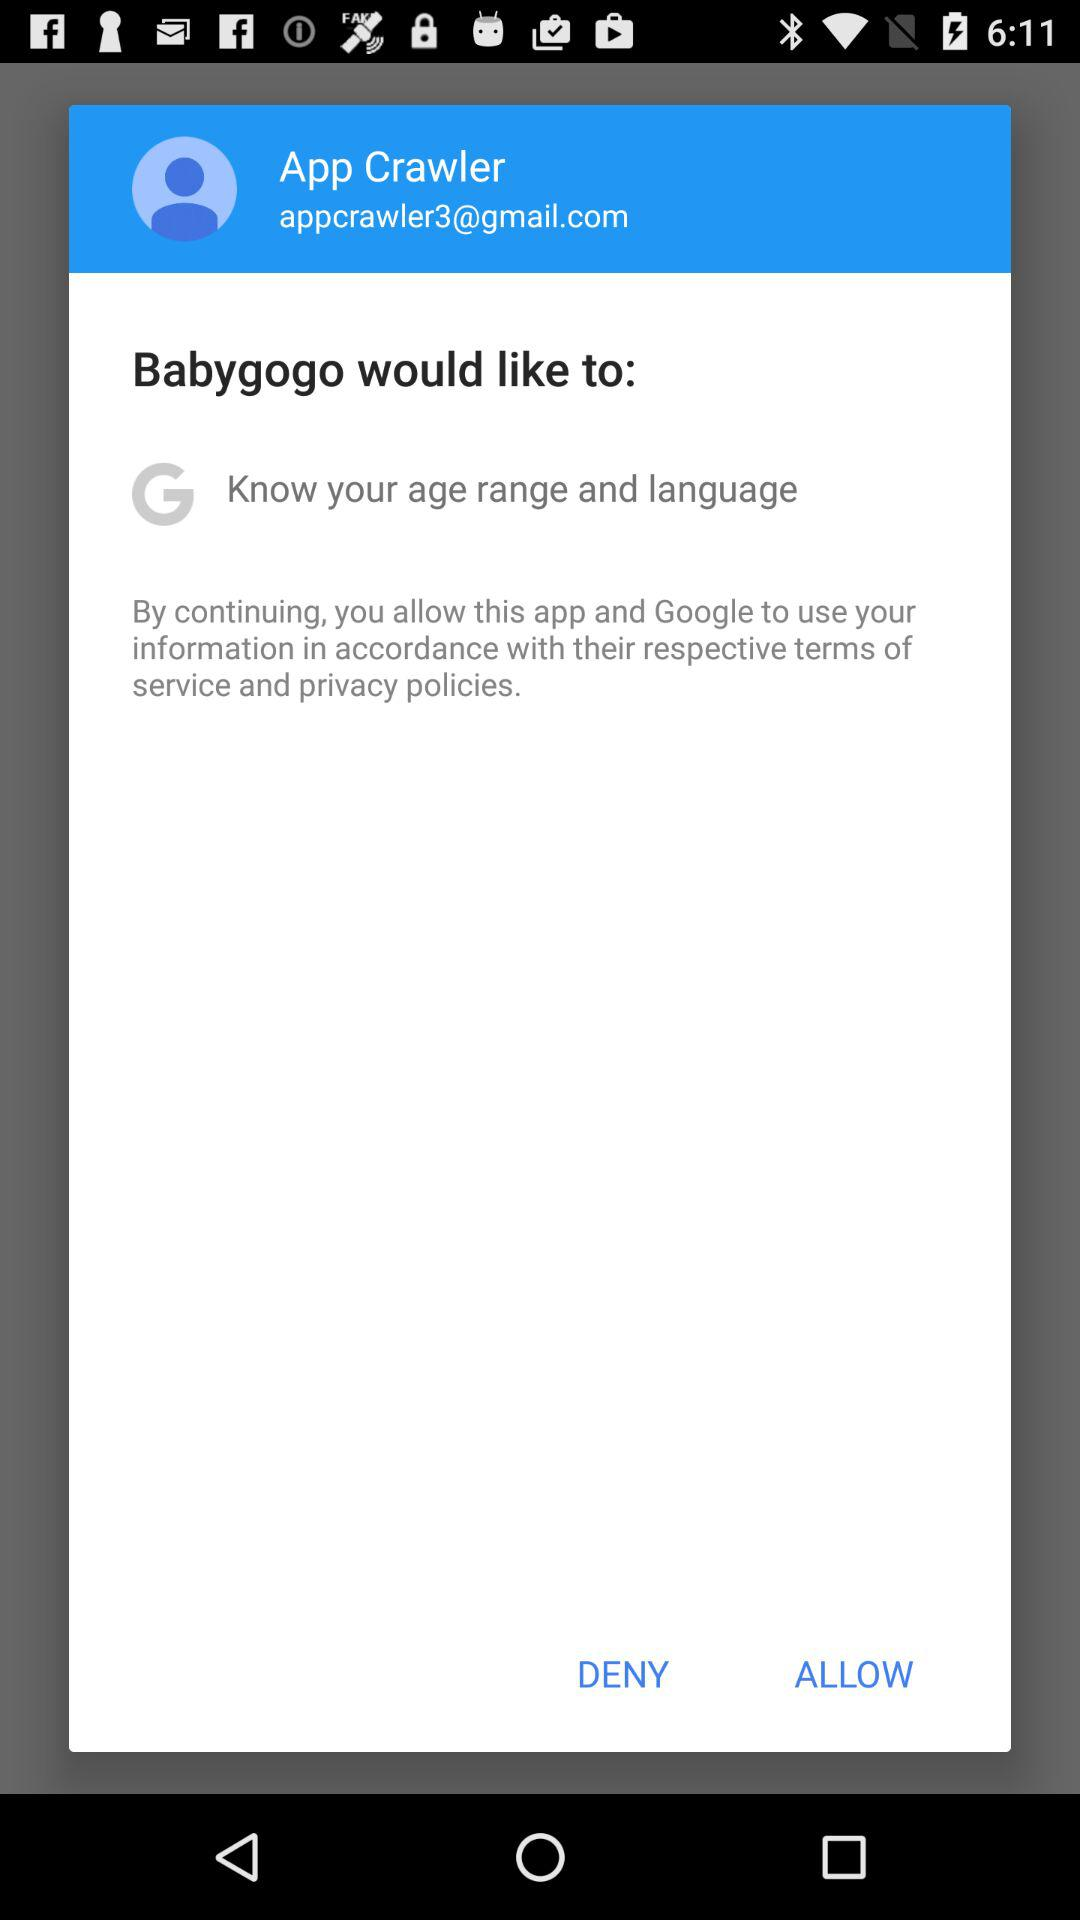What is the name of the user? The name of the user is App Crawler. 